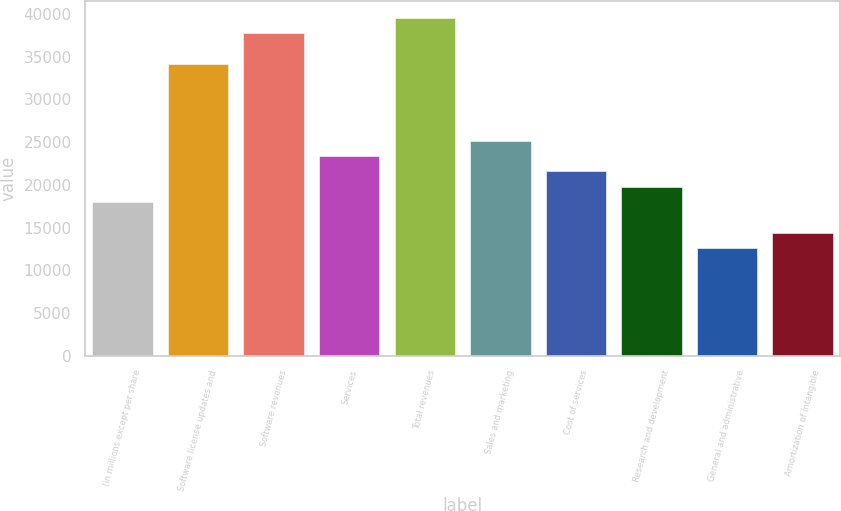Convert chart to OTSL. <chart><loc_0><loc_0><loc_500><loc_500><bar_chart><fcel>(in millions except per share<fcel>Software license updates and<fcel>Software revenues<fcel>Services<fcel>Total revenues<fcel>Sales and marketing<fcel>Cost of services<fcel>Research and development<fcel>General and administrative<fcel>Amortization of intangible<nl><fcel>17996<fcel>34175.3<fcel>37770.7<fcel>23389.1<fcel>39568.4<fcel>25186.8<fcel>21591.4<fcel>19793.7<fcel>12602.9<fcel>14400.6<nl></chart> 